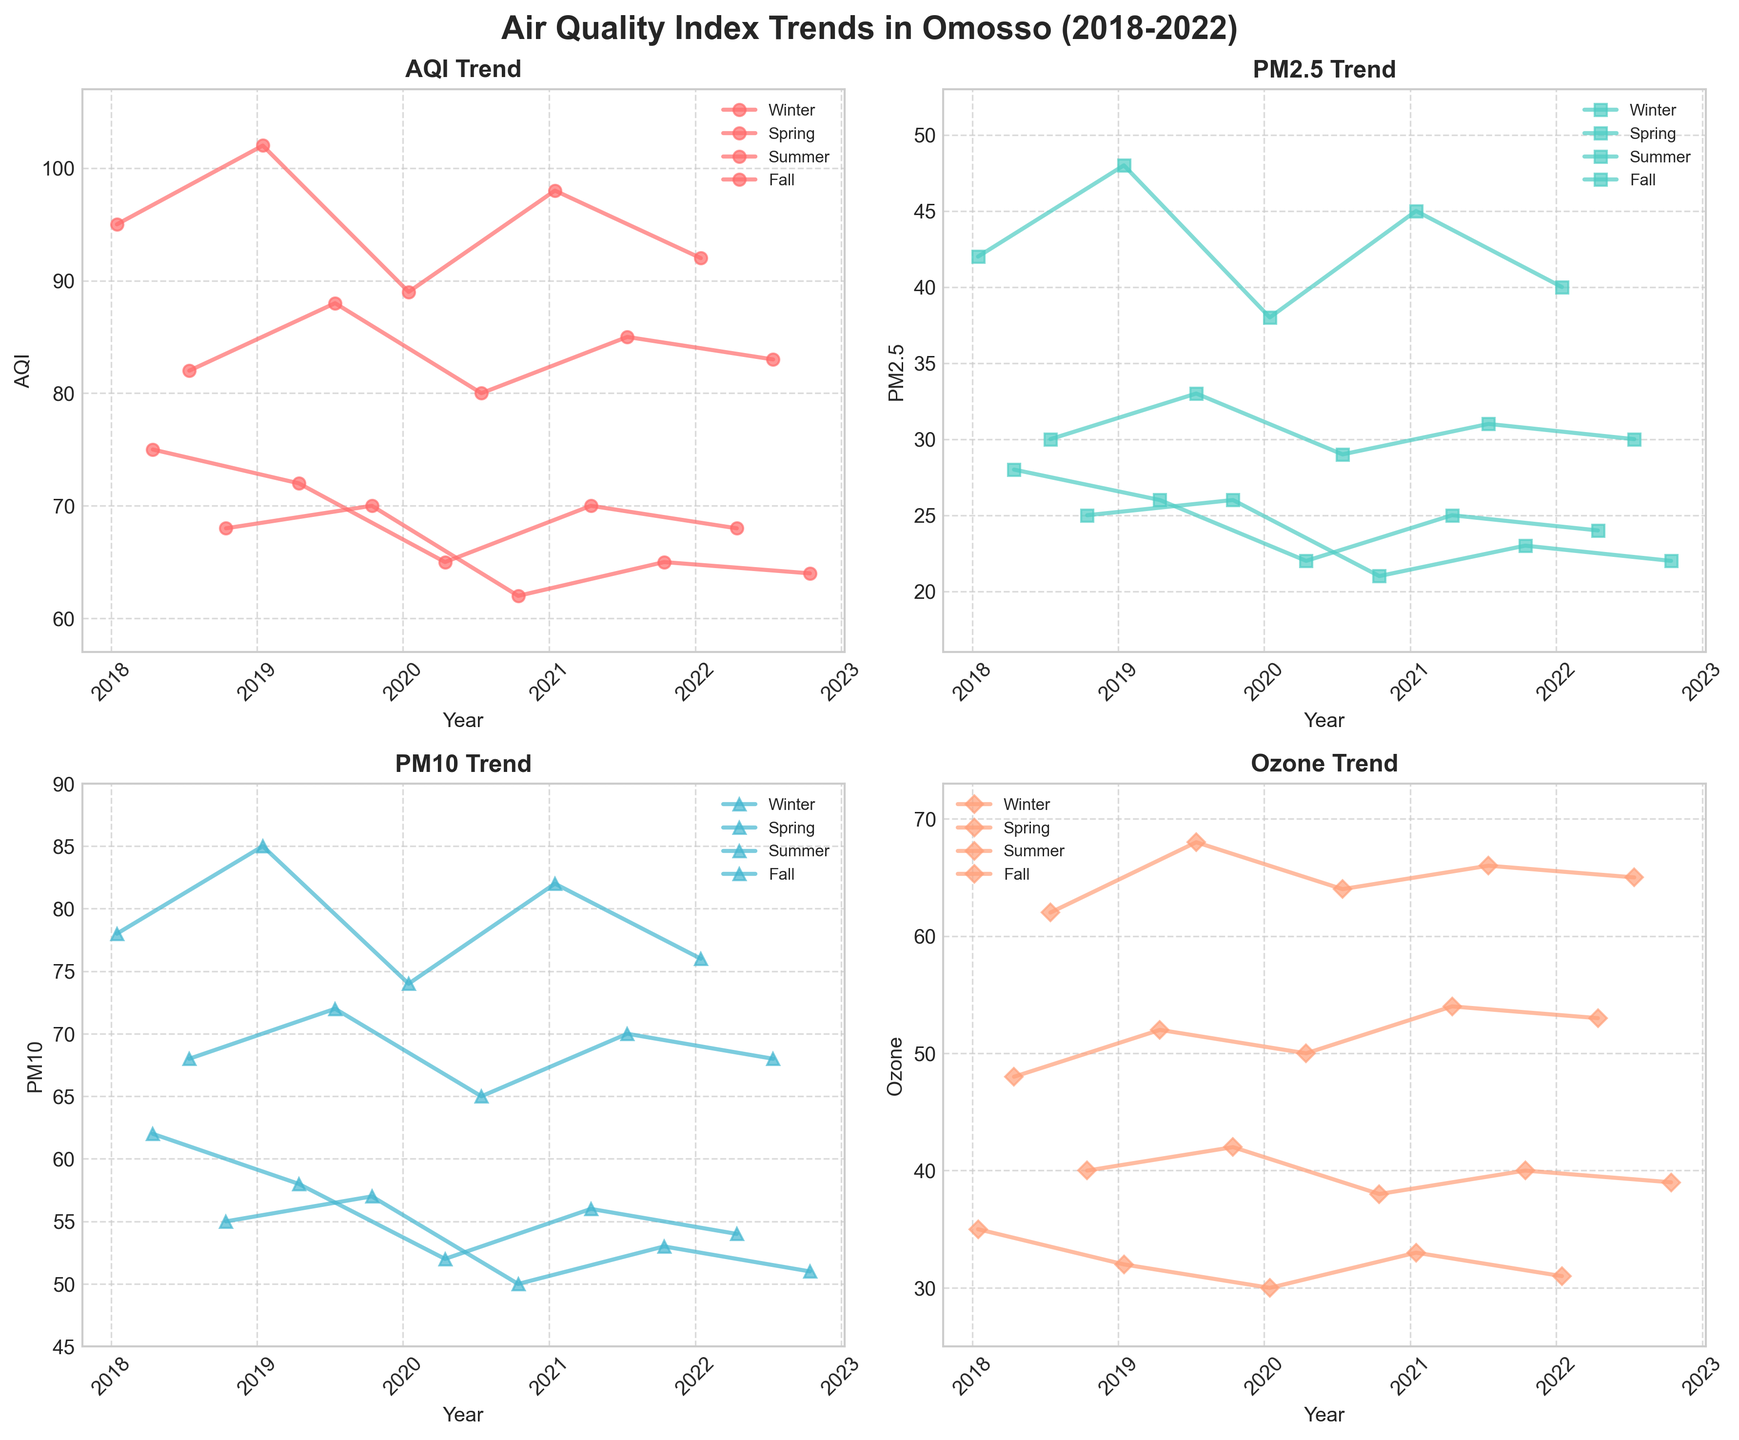What is the title of the figure? The title is usually at the top of the figure. In this case, it is located above all the subplots.
Answer: Air Quality Index Trends in Omosso (2018-2022) Which season has the highest AQI value in 2021? To find this, look for the year 2021 on the AQI Trend subplot and identify the highest peak among the seasonal lines.
Answer: Winter What pattern is observed in the PM2.5 values across seasons? Observe the PM2.5 Trend subplot and note how PM2.5 values change in each season over the years.
Answer: Decreases from Winter to Fall Comparing Winter and Summer, in which season do we see higher PM10 values? Look at the PM10 Trend subplot and compare the peaks and trends of the Winter and Summer lines across multiple years.
Answer: Winter What is the overall trend for Ozone levels from 2018 to 2022? Follow the Ozone Trend subplot and evaluate the direction of the lines over the span of years.
Answer: Increasing Which year shows the lowest AQI in Spring? Identify the dates corresponding to Spring on the AQI Trend subplot and locate the year with the lowest value.
Answer: 2020 In which season does the AQI seem to fluctuate the most visually? Examine the AQI Trend subplot and evaluate the deviations of the AQI values for each season.
Answer: Winter What is the difference in Summer AQI between 2018 and 2022? Check the Summer line on the AQI Trend subplot for the points corresponding to 2018 and 2022, then calculate the difference between these values.
Answer: 1 How does the Fall season PM2.5 value in 2019 compare to 2021? Look at the PM2.5 Trend subplot for data points from Fall in 2019 and 2021, then compare these specific values.
Answer: 2019 is higher Describe the trend in Winter Ozone levels from 2018 to 2022. Follow the Winter line on the Ozone Trend subplot and analyze the direction of the Ozone levels from start to end.
Answer: Decreasing 